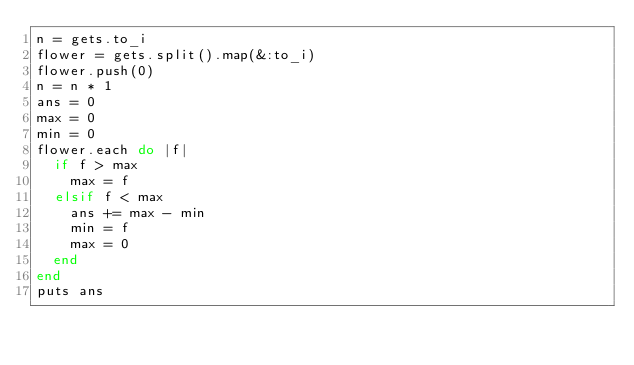Convert code to text. <code><loc_0><loc_0><loc_500><loc_500><_Ruby_>n = gets.to_i
flower = gets.split().map(&:to_i)
flower.push(0)
n = n * 1
ans = 0
max = 0
min = 0
flower.each do |f|
  if f > max
    max = f
  elsif f < max
    ans += max - min
    min = f
    max = 0
  end
end
puts ans</code> 